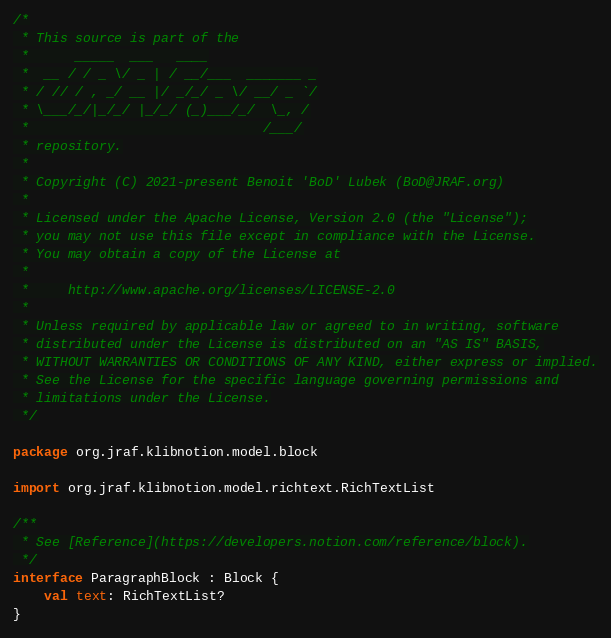<code> <loc_0><loc_0><loc_500><loc_500><_Kotlin_>/*
 * This source is part of the
 *      _____  ___   ____
 *  __ / / _ \/ _ | / __/___  _______ _
 * / // / , _/ __ |/ _/_/ _ \/ __/ _ `/
 * \___/_/|_/_/ |_/_/ (_)___/_/  \_, /
 *                              /___/
 * repository.
 *
 * Copyright (C) 2021-present Benoit 'BoD' Lubek (BoD@JRAF.org)
 *
 * Licensed under the Apache License, Version 2.0 (the "License");
 * you may not use this file except in compliance with the License.
 * You may obtain a copy of the License at
 *
 *     http://www.apache.org/licenses/LICENSE-2.0
 *
 * Unless required by applicable law or agreed to in writing, software
 * distributed under the License is distributed on an "AS IS" BASIS,
 * WITHOUT WARRANTIES OR CONDITIONS OF ANY KIND, either express or implied.
 * See the License for the specific language governing permissions and
 * limitations under the License.
 */

package org.jraf.klibnotion.model.block

import org.jraf.klibnotion.model.richtext.RichTextList

/**
 * See [Reference](https://developers.notion.com/reference/block).
 */
interface ParagraphBlock : Block {
    val text: RichTextList?
}</code> 